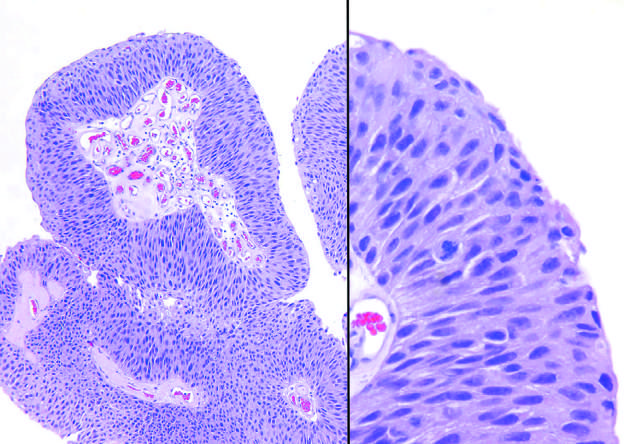does higher magnification show slightly irregular nuclei with scattered mitotic figures?
Answer the question using a single word or phrase. Yes 